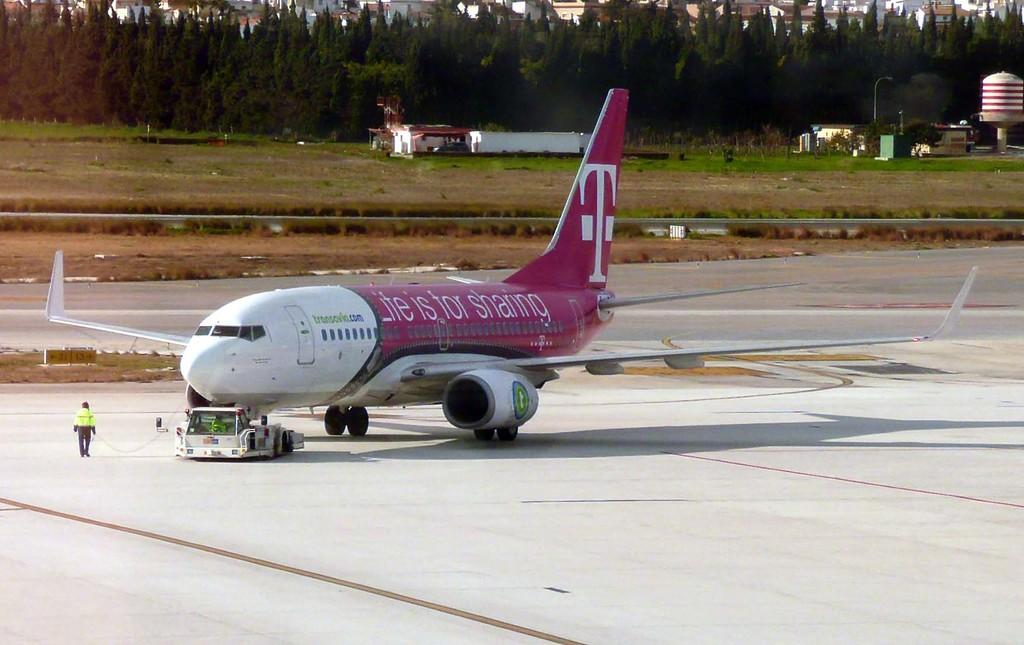Provide a one-sentence caption for the provided image. Transavia.com logo and Lite is for sharing logo for T mobile on a airplane. 